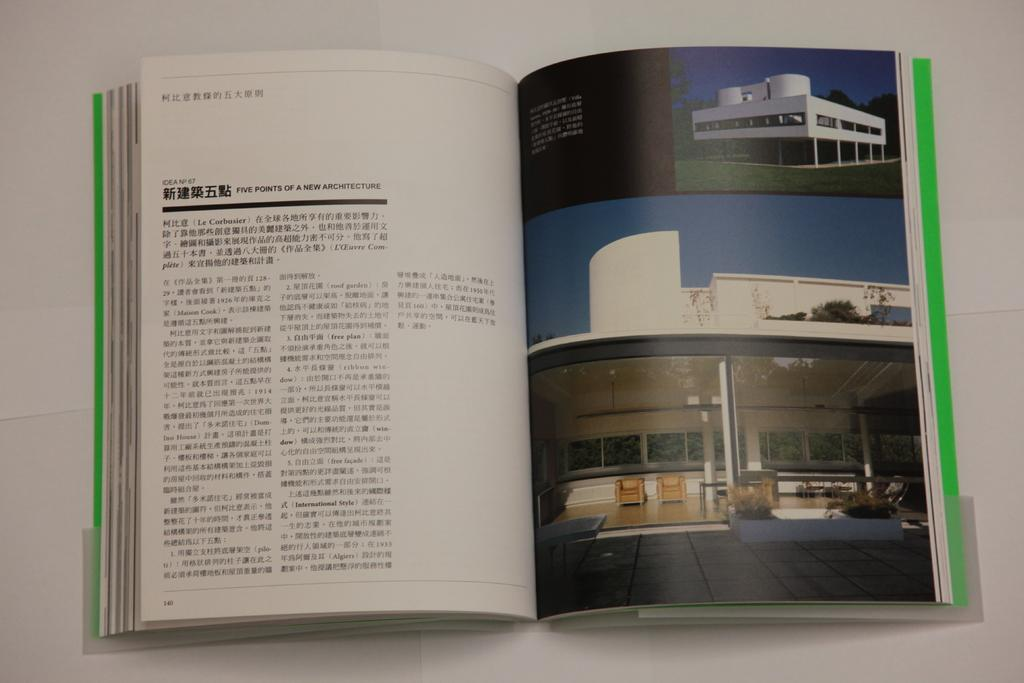<image>
Summarize the visual content of the image. An architecture book is open to a page about five points of new architecture. 